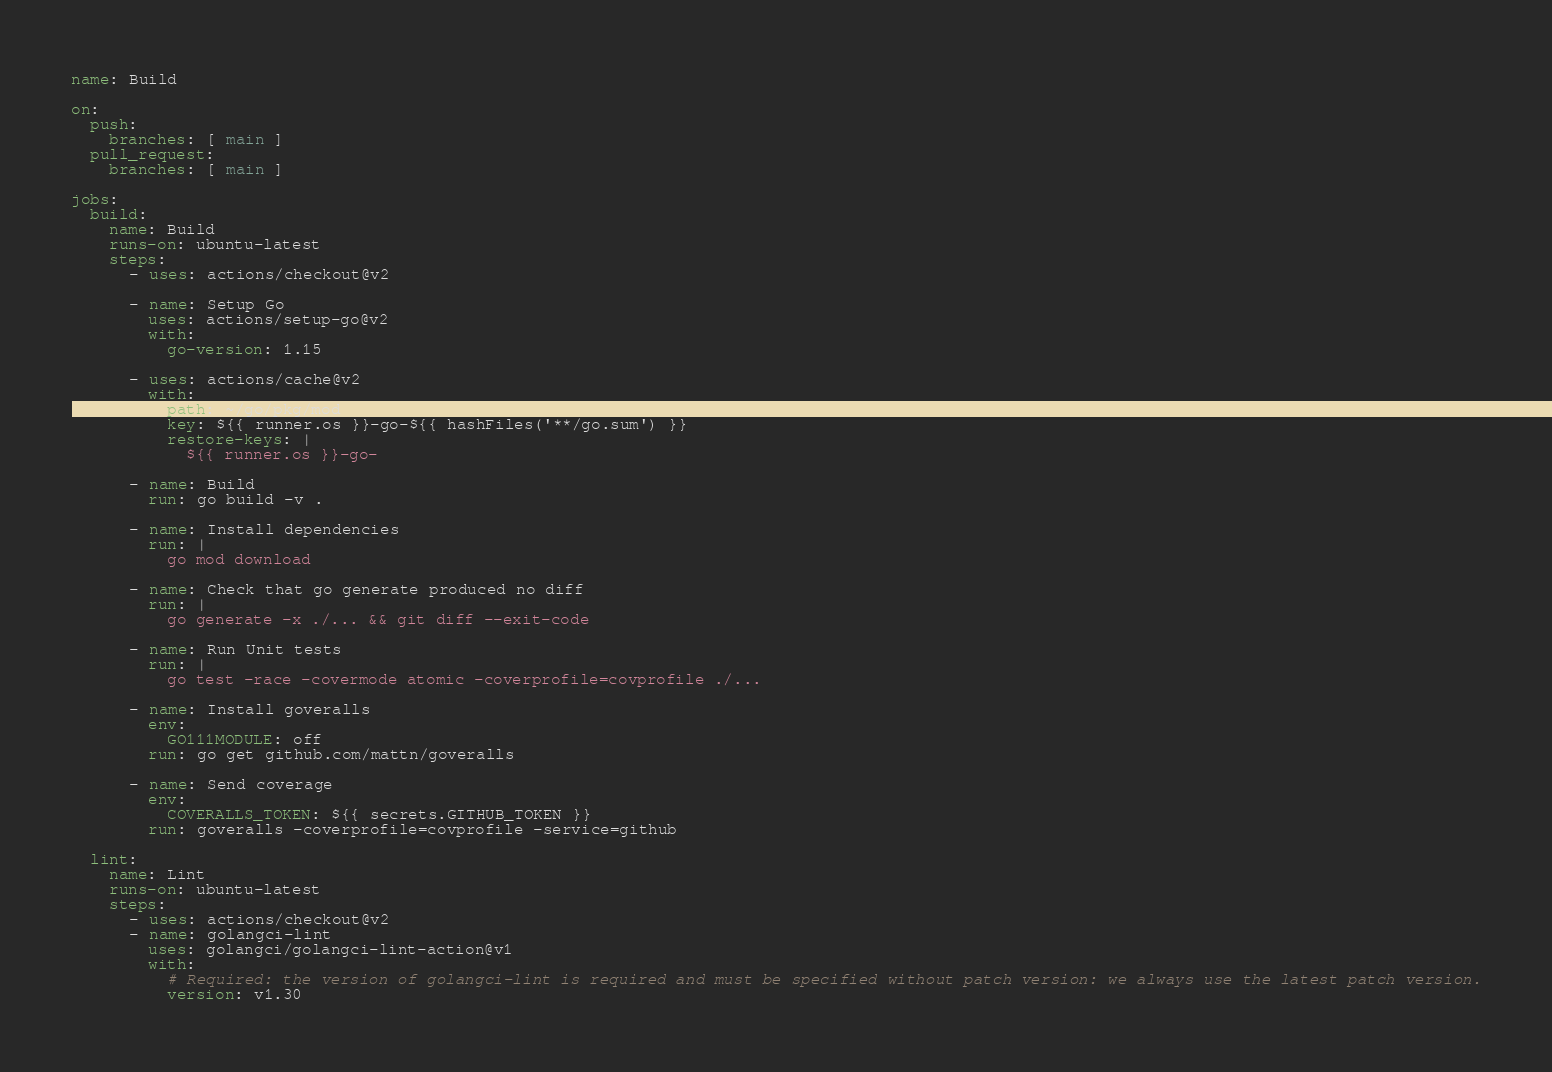<code> <loc_0><loc_0><loc_500><loc_500><_YAML_>name: Build

on:
  push:
    branches: [ main ]
  pull_request:
    branches: [ main ]

jobs:
  build:
    name: Build
    runs-on: ubuntu-latest
    steps:
      - uses: actions/checkout@v2

      - name: Setup Go
        uses: actions/setup-go@v2
        with:
          go-version: 1.15

      - uses: actions/cache@v2
        with:
          path: ~/go/pkg/mod
          key: ${{ runner.os }}-go-${{ hashFiles('**/go.sum') }}
          restore-keys: |
            ${{ runner.os }}-go-

      - name: Build
        run: go build -v .

      - name: Install dependencies
        run: |
          go mod download

      - name: Check that go generate produced no diff
        run: |
          go generate -x ./... && git diff --exit-code

      - name: Run Unit tests
        run: |
          go test -race -covermode atomic -coverprofile=covprofile ./...

      - name: Install goveralls
        env:
          GO111MODULE: off
        run: go get github.com/mattn/goveralls

      - name: Send coverage
        env:
          COVERALLS_TOKEN: ${{ secrets.GITHUB_TOKEN }}
        run: goveralls -coverprofile=covprofile -service=github

  lint:
    name: Lint
    runs-on: ubuntu-latest
    steps:
      - uses: actions/checkout@v2
      - name: golangci-lint
        uses: golangci/golangci-lint-action@v1
        with:
          # Required: the version of golangci-lint is required and must be specified without patch version: we always use the latest patch version.
          version: v1.30
</code> 